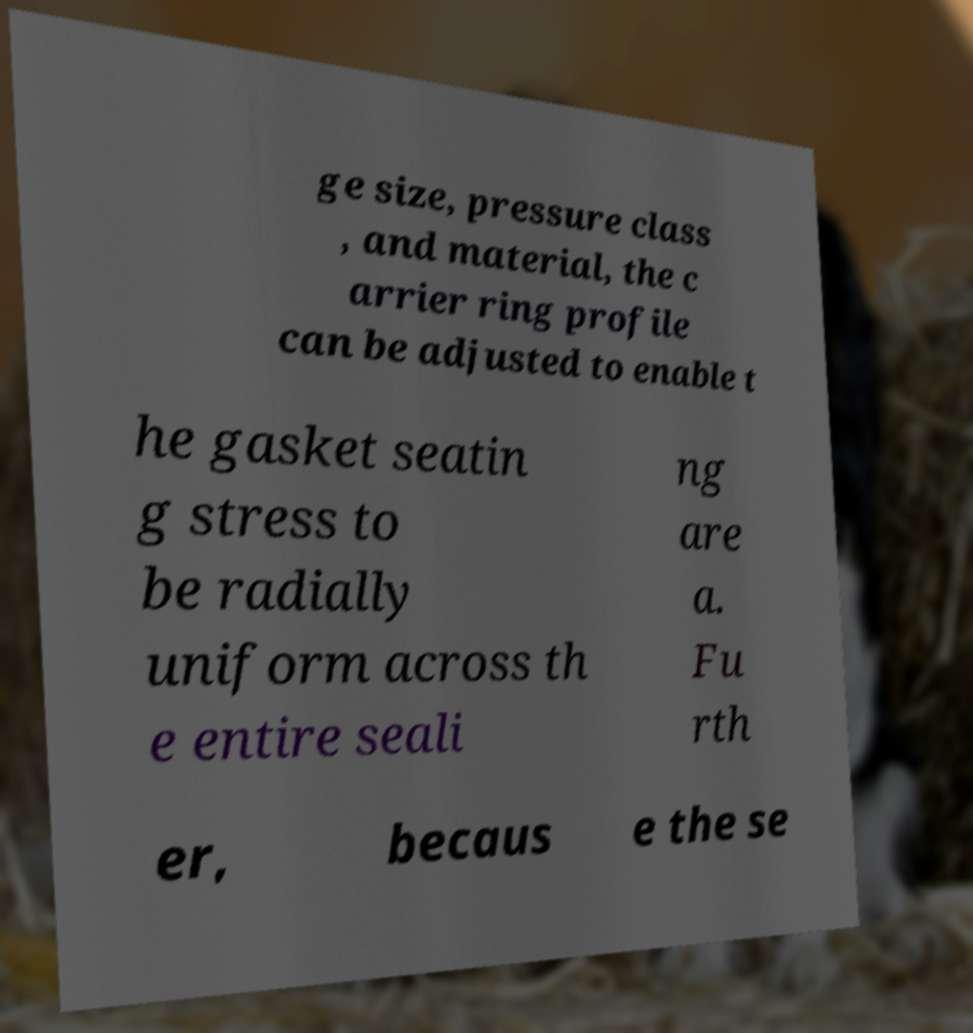What messages or text are displayed in this image? I need them in a readable, typed format. ge size, pressure class , and material, the c arrier ring profile can be adjusted to enable t he gasket seatin g stress to be radially uniform across th e entire seali ng are a. Fu rth er, becaus e the se 